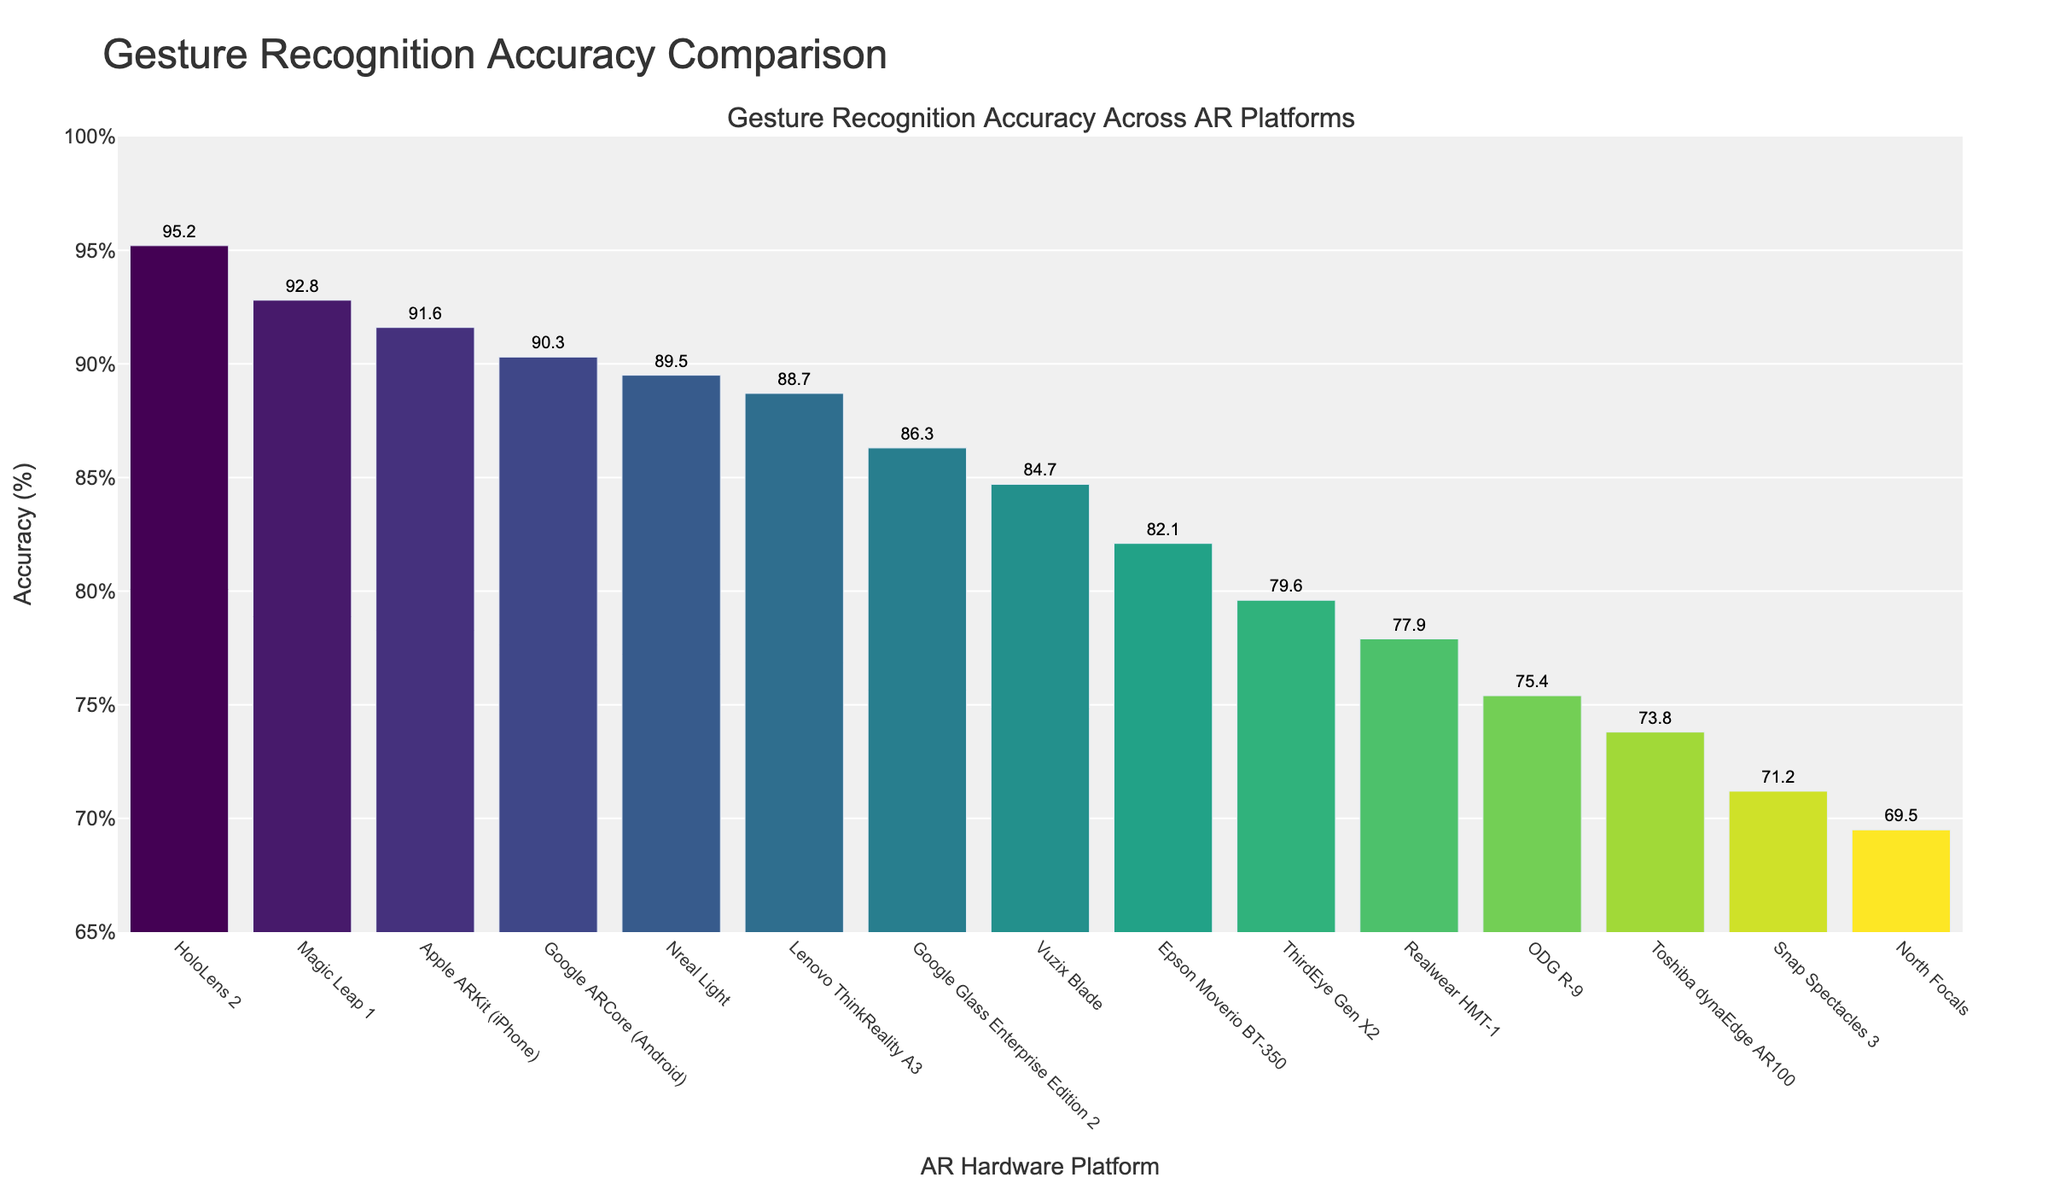Which AR hardware platform has the highest gesture recognition accuracy? The platform with the highest bar in the chart represents the highest gesture recognition accuracy. This is HoloLens 2 with an accuracy of 95.2%.
Answer: HoloLens 2 Which platform has a higher gesture recognition accuracy, Magic Leap 1 or Google ARCore (Android)? By comparing the heights of the bars for Magic Leap 1 and Google ARCore (Android), Magic Leap 1 has a marginally greater height indicating a higher accuracy of 92.8% compared to 90.3%.
Answer: Magic Leap 1 What is the average gesture recognition accuracy of the top 3 AR hardware platforms? The accuracies of the top 3 platforms are HoloLens 2 (95.2%), Magic Leap 1 (92.8%), and Apple ARKit (iPhone) (91.6%). Their sum is 95.2 + 92.8 + 91.6 = 279.6, and the average is 279.6 / 3 ≈ 93.2%.
Answer: ~93.2% How much greater is the gesture recognition accuracy of HoloLens 2 compared to North Focals? The accuracy for HoloLens 2 is 95.2% and for North Focals it is 69.5%. The difference is 95.2 - 69.5 = 25.7%.
Answer: 25.7% Is the gesture recognition accuracy of Nreal Light closer to that of Lenovo ThinkReality A3 or Google ARCore (Android)? Nreal Light has an accuracy of 89.5%, Lenovo ThinkReality A3 has 88.7%, and Google ARCore (Android) has 90.3%. The absolute differences are 89.5 - 88.7 = 0.8 and 90.3 - 89.5 = 0.8, indicating it’s equally close to both.
Answer: Both equally Which platform has the lowest gesture recognition accuracy? The platform with the shortest bar indicates the lowest gesture recognition accuracy, which is North Focals with an accuracy of 69.5%.
Answer: North Focals What is the difference in gesture recognition accuracy between Vuzix Blade and Google Glass Enterprise Edition 2? The accuracy for Vuzix Blade is 84.7% and for Google Glass Enterprise Edition 2 is 86.3%. The difference is 86.3 - 84.7 = 1.6%.
Answer: 1.6% Are most AR hardware platforms' gesture recognition accuracies below 85%? By counting the bars with heights representing accuracies below 85%, there are 8 out of the 14 listed platforms below this threshold. Most platforms indeed have accuracies lower than 85%.
Answer: Yes What is the combined gesture recognition accuracy for platforms Magic Leap 1, Epson Moverio BT-350, and ThirdEye Gen X2? The accuracies are Magic Leap 1 (92.8%), Epson Moverio BT-350 (82.1%), and ThirdEye Gen X2 (79.6%). Adding these gives 92.8 + 82.1 + 79.6 = 254.5%.
Answer: 254.5% What is the average gesture recognition accuracy for all the AR hardware platforms shown in the figure? To find the average, sum all given accuracies: 95.2 + 92.8 + 89.5 + 86.3 + 84.7 + 82.1 + 79.6 + 77.9 + 75.4 + 73.8 + 88.7 + 71.2 + 69.5 + 91.6 + 90.3 = 1248.6. Divide by number of platforms, 1248.6 / 15 ≈ 83.24%.
Answer: ~83.24% 